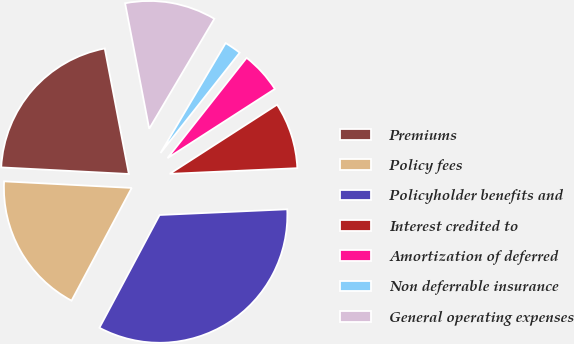Convert chart to OTSL. <chart><loc_0><loc_0><loc_500><loc_500><pie_chart><fcel>Premiums<fcel>Policy fees<fcel>Policyholder benefits and<fcel>Interest credited to<fcel>Amortization of deferred<fcel>Non deferrable insurance<fcel>General operating expenses<nl><fcel>21.16%<fcel>18.02%<fcel>33.51%<fcel>8.4%<fcel>5.26%<fcel>2.12%<fcel>11.53%<nl></chart> 